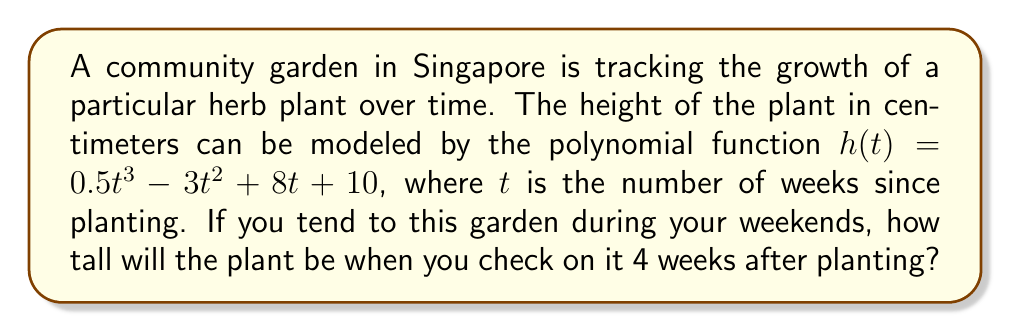What is the answer to this math problem? To find the height of the plant 4 weeks after planting, we need to evaluate the polynomial function $h(t)$ at $t = 4$. Let's break this down step-by-step:

1) The given function is $h(t) = 0.5t^3 - 3t^2 + 8t + 10$

2) We need to calculate $h(4)$, so we substitute $t = 4$ into the function:

   $h(4) = 0.5(4)^3 - 3(4)^2 + 8(4) + 10$

3) Let's evaluate each term:
   - $0.5(4)^3 = 0.5 \cdot 64 = 32$
   - $3(4)^2 = 3 \cdot 16 = 48$
   - $8(4) = 32$
   - The constant term is already 10

4) Now, we can rewrite our equation:

   $h(4) = 32 - 48 + 32 + 10$

5) Simplifying:
   $h(4) = 26$

Therefore, 4 weeks after planting, the herb plant will be 26 cm tall.
Answer: $26$ cm 